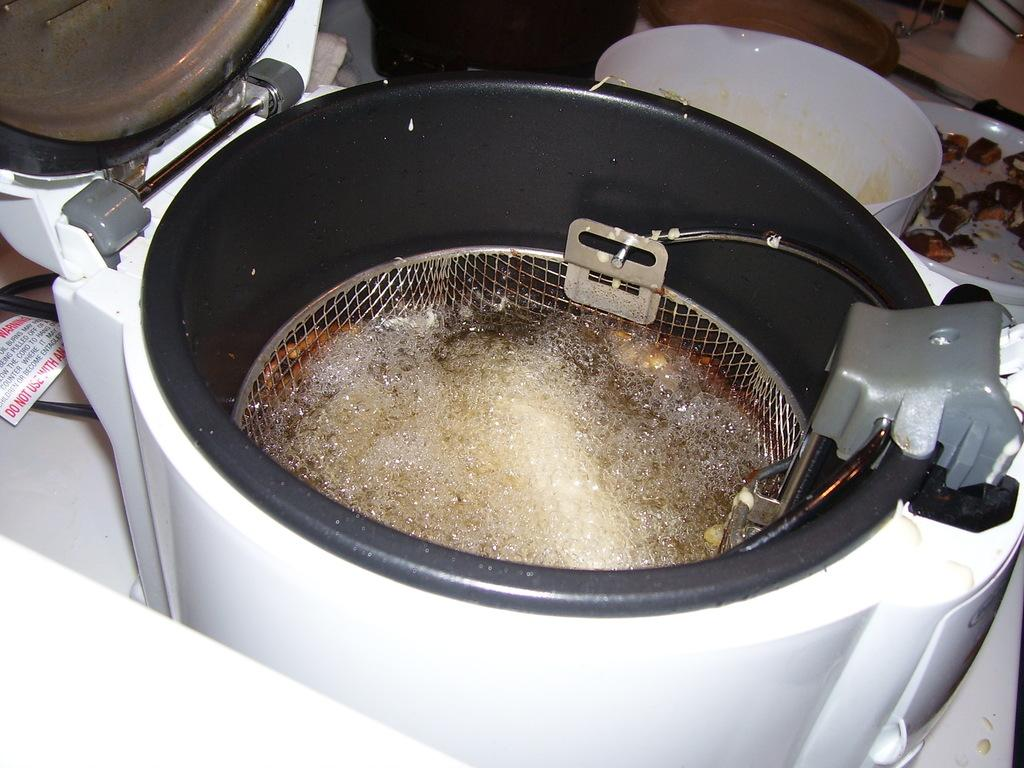What appliance is visible in the picture? There is an air fryer in the picture. Where are the bowls located in the image? The bowls are on the top right side of the image. Can you see any cobwebs in the image? There is no mention of cobwebs in the provided facts, and therefore we cannot determine if any are present in the image. 